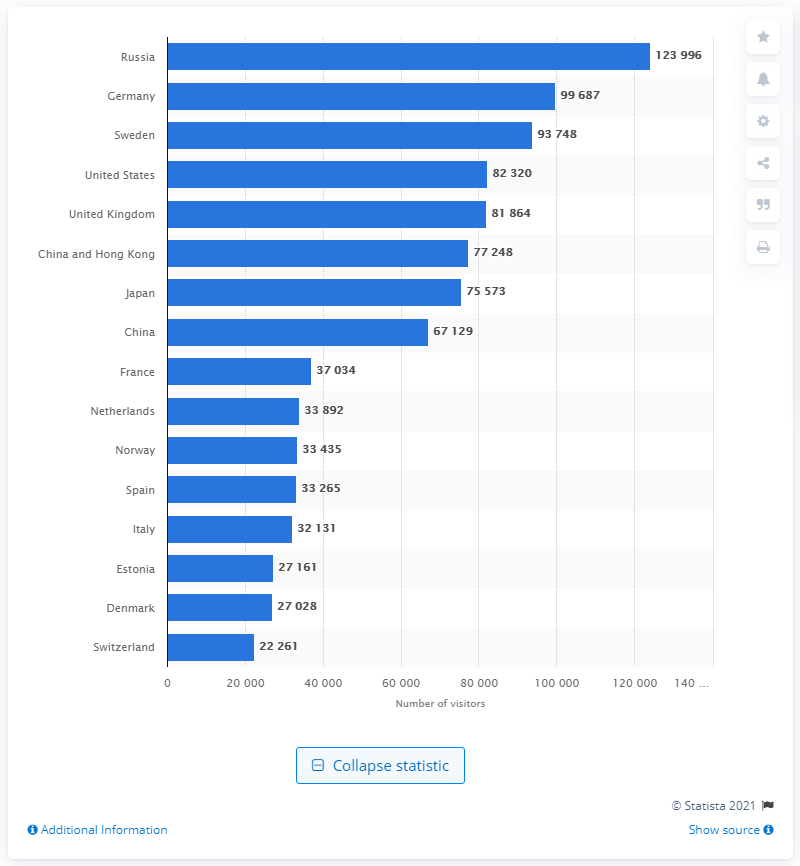Identify some key points in this picture. In 2019, a total of 99,687 German nationals visited Helsinki. In 2019, the number of Russian visitors to Helsinki was 123,996. 